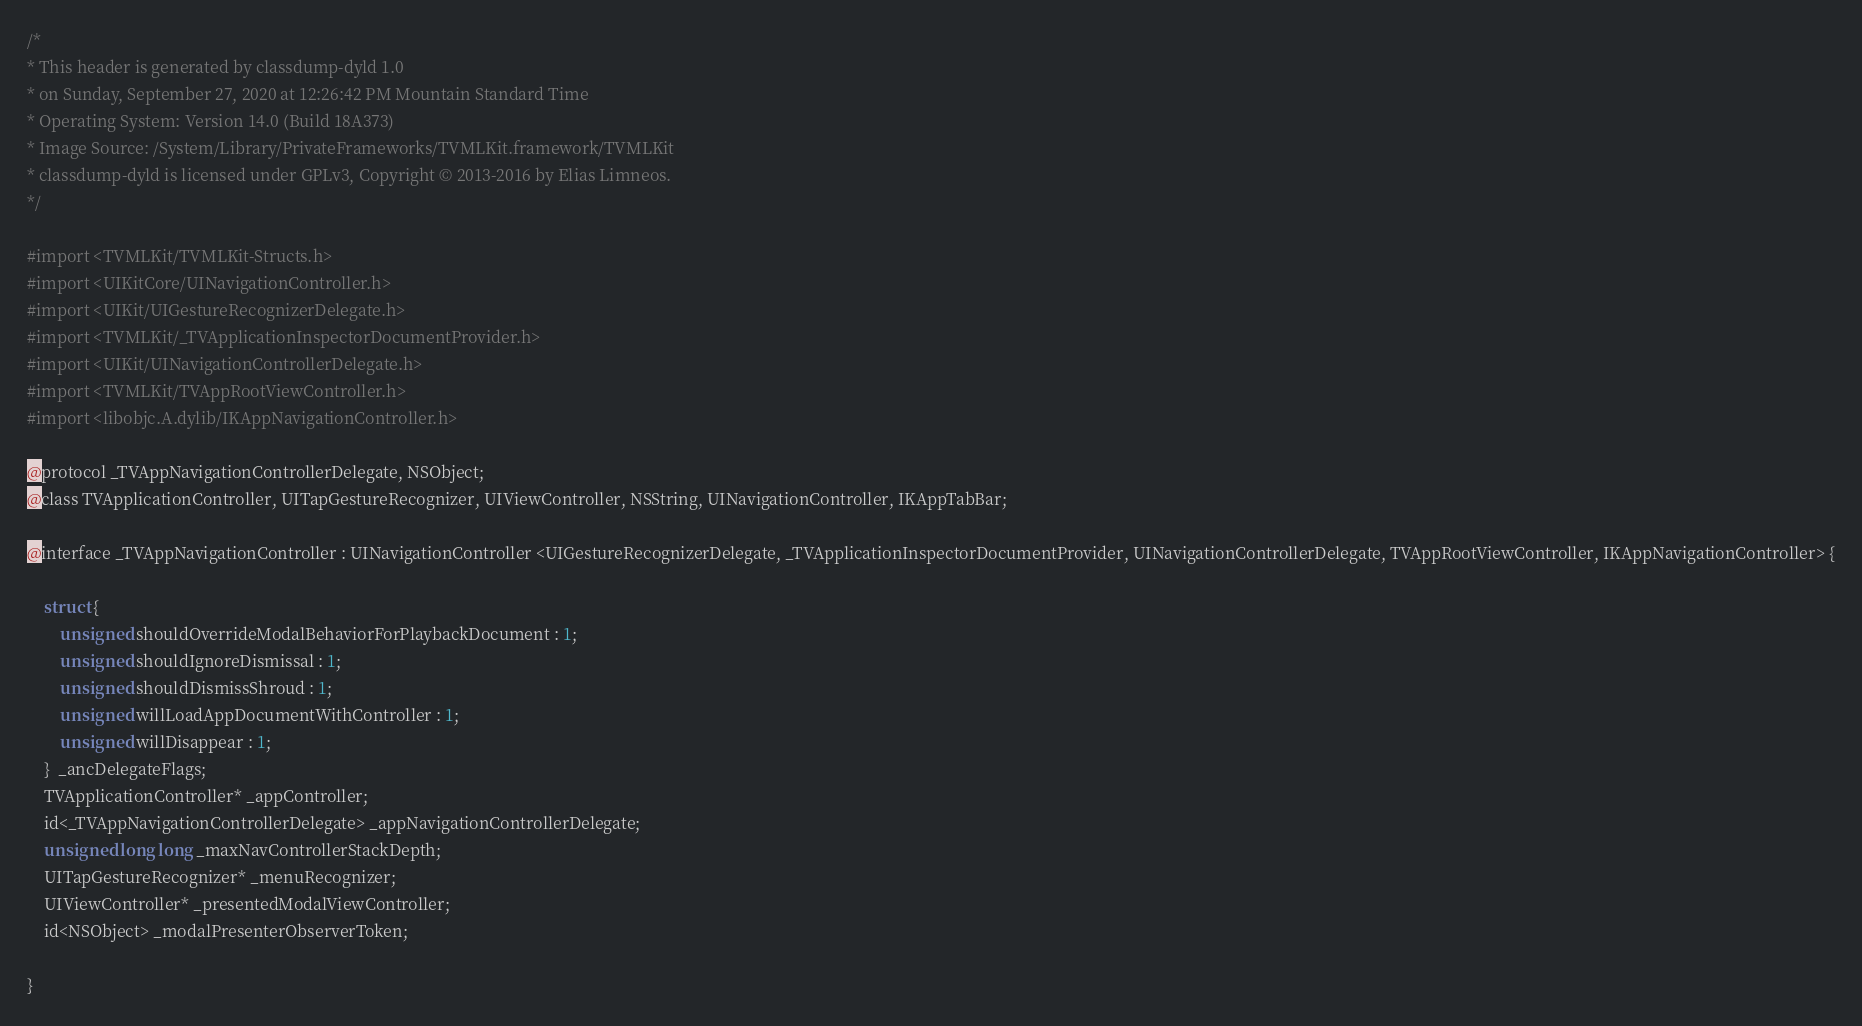<code> <loc_0><loc_0><loc_500><loc_500><_C_>/*
* This header is generated by classdump-dyld 1.0
* on Sunday, September 27, 2020 at 12:26:42 PM Mountain Standard Time
* Operating System: Version 14.0 (Build 18A373)
* Image Source: /System/Library/PrivateFrameworks/TVMLKit.framework/TVMLKit
* classdump-dyld is licensed under GPLv3, Copyright © 2013-2016 by Elias Limneos.
*/

#import <TVMLKit/TVMLKit-Structs.h>
#import <UIKitCore/UINavigationController.h>
#import <UIKit/UIGestureRecognizerDelegate.h>
#import <TVMLKit/_TVApplicationInspectorDocumentProvider.h>
#import <UIKit/UINavigationControllerDelegate.h>
#import <TVMLKit/TVAppRootViewController.h>
#import <libobjc.A.dylib/IKAppNavigationController.h>

@protocol _TVAppNavigationControllerDelegate, NSObject;
@class TVApplicationController, UITapGestureRecognizer, UIViewController, NSString, UINavigationController, IKAppTabBar;

@interface _TVAppNavigationController : UINavigationController <UIGestureRecognizerDelegate, _TVApplicationInspectorDocumentProvider, UINavigationControllerDelegate, TVAppRootViewController, IKAppNavigationController> {

	struct {
		unsigned shouldOverrideModalBehaviorForPlaybackDocument : 1;
		unsigned shouldIgnoreDismissal : 1;
		unsigned shouldDismissShroud : 1;
		unsigned willLoadAppDocumentWithController : 1;
		unsigned willDisappear : 1;
	}  _ancDelegateFlags;
	TVApplicationController* _appController;
	id<_TVAppNavigationControllerDelegate> _appNavigationControllerDelegate;
	unsigned long long _maxNavControllerStackDepth;
	UITapGestureRecognizer* _menuRecognizer;
	UIViewController* _presentedModalViewController;
	id<NSObject> _modalPresenterObserverToken;

}
</code> 